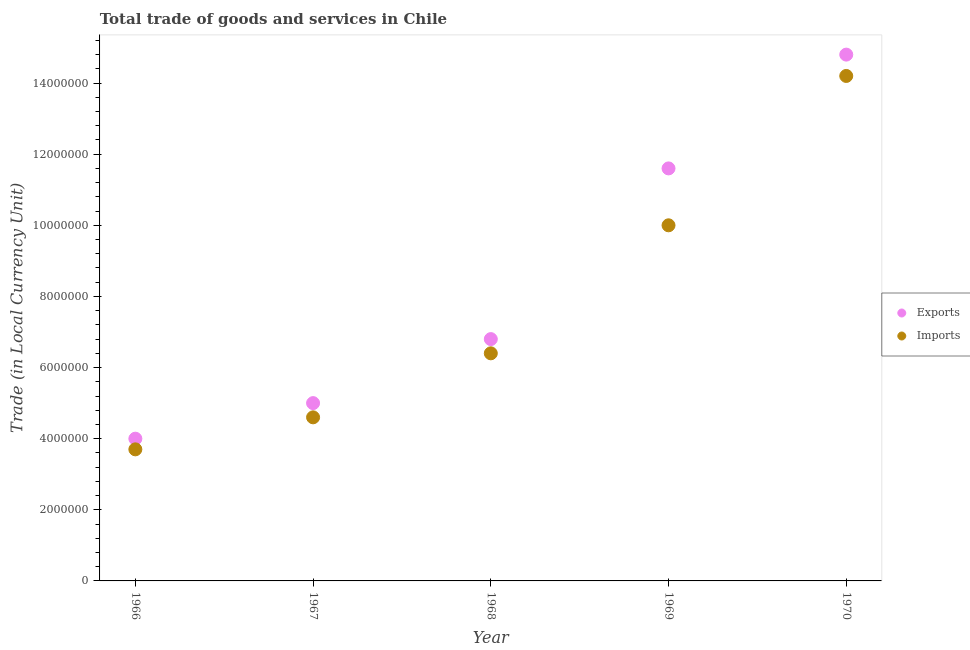How many different coloured dotlines are there?
Your answer should be very brief. 2. What is the imports of goods and services in 1970?
Your answer should be compact. 1.42e+07. Across all years, what is the maximum export of goods and services?
Provide a succinct answer. 1.48e+07. Across all years, what is the minimum imports of goods and services?
Ensure brevity in your answer.  3.70e+06. In which year was the imports of goods and services maximum?
Offer a very short reply. 1970. In which year was the imports of goods and services minimum?
Your answer should be compact. 1966. What is the total imports of goods and services in the graph?
Ensure brevity in your answer.  3.89e+07. What is the difference between the export of goods and services in 1966 and that in 1968?
Keep it short and to the point. -2.80e+06. What is the difference between the export of goods and services in 1968 and the imports of goods and services in 1967?
Provide a succinct answer. 2.20e+06. What is the average export of goods and services per year?
Offer a terse response. 8.44e+06. In the year 1969, what is the difference between the imports of goods and services and export of goods and services?
Offer a very short reply. -1.60e+06. What is the ratio of the imports of goods and services in 1967 to that in 1969?
Your answer should be very brief. 0.46. Is the imports of goods and services in 1966 less than that in 1970?
Provide a short and direct response. Yes. Is the difference between the export of goods and services in 1967 and 1970 greater than the difference between the imports of goods and services in 1967 and 1970?
Keep it short and to the point. No. What is the difference between the highest and the second highest imports of goods and services?
Keep it short and to the point. 4.20e+06. What is the difference between the highest and the lowest imports of goods and services?
Keep it short and to the point. 1.05e+07. How many years are there in the graph?
Your answer should be compact. 5. What is the difference between two consecutive major ticks on the Y-axis?
Give a very brief answer. 2.00e+06. Does the graph contain any zero values?
Offer a terse response. No. How are the legend labels stacked?
Your answer should be very brief. Vertical. What is the title of the graph?
Offer a terse response. Total trade of goods and services in Chile. Does "Nitrous oxide" appear as one of the legend labels in the graph?
Ensure brevity in your answer.  No. What is the label or title of the X-axis?
Provide a succinct answer. Year. What is the label or title of the Y-axis?
Provide a succinct answer. Trade (in Local Currency Unit). What is the Trade (in Local Currency Unit) in Exports in 1966?
Offer a terse response. 4.00e+06. What is the Trade (in Local Currency Unit) of Imports in 1966?
Ensure brevity in your answer.  3.70e+06. What is the Trade (in Local Currency Unit) in Imports in 1967?
Offer a very short reply. 4.60e+06. What is the Trade (in Local Currency Unit) in Exports in 1968?
Offer a very short reply. 6.80e+06. What is the Trade (in Local Currency Unit) in Imports in 1968?
Your answer should be compact. 6.40e+06. What is the Trade (in Local Currency Unit) in Exports in 1969?
Provide a succinct answer. 1.16e+07. What is the Trade (in Local Currency Unit) in Exports in 1970?
Offer a very short reply. 1.48e+07. What is the Trade (in Local Currency Unit) in Imports in 1970?
Offer a terse response. 1.42e+07. Across all years, what is the maximum Trade (in Local Currency Unit) of Exports?
Make the answer very short. 1.48e+07. Across all years, what is the maximum Trade (in Local Currency Unit) of Imports?
Your answer should be compact. 1.42e+07. Across all years, what is the minimum Trade (in Local Currency Unit) in Imports?
Keep it short and to the point. 3.70e+06. What is the total Trade (in Local Currency Unit) in Exports in the graph?
Your answer should be compact. 4.22e+07. What is the total Trade (in Local Currency Unit) in Imports in the graph?
Keep it short and to the point. 3.89e+07. What is the difference between the Trade (in Local Currency Unit) in Imports in 1966 and that in 1967?
Provide a succinct answer. -9.00e+05. What is the difference between the Trade (in Local Currency Unit) of Exports in 1966 and that in 1968?
Make the answer very short. -2.80e+06. What is the difference between the Trade (in Local Currency Unit) in Imports in 1966 and that in 1968?
Offer a very short reply. -2.70e+06. What is the difference between the Trade (in Local Currency Unit) of Exports in 1966 and that in 1969?
Your answer should be compact. -7.60e+06. What is the difference between the Trade (in Local Currency Unit) in Imports in 1966 and that in 1969?
Your answer should be very brief. -6.30e+06. What is the difference between the Trade (in Local Currency Unit) in Exports in 1966 and that in 1970?
Your answer should be compact. -1.08e+07. What is the difference between the Trade (in Local Currency Unit) of Imports in 1966 and that in 1970?
Offer a very short reply. -1.05e+07. What is the difference between the Trade (in Local Currency Unit) of Exports in 1967 and that in 1968?
Your answer should be very brief. -1.80e+06. What is the difference between the Trade (in Local Currency Unit) in Imports in 1967 and that in 1968?
Offer a very short reply. -1.80e+06. What is the difference between the Trade (in Local Currency Unit) in Exports in 1967 and that in 1969?
Offer a very short reply. -6.60e+06. What is the difference between the Trade (in Local Currency Unit) in Imports in 1967 and that in 1969?
Your response must be concise. -5.40e+06. What is the difference between the Trade (in Local Currency Unit) of Exports in 1967 and that in 1970?
Offer a very short reply. -9.80e+06. What is the difference between the Trade (in Local Currency Unit) of Imports in 1967 and that in 1970?
Keep it short and to the point. -9.60e+06. What is the difference between the Trade (in Local Currency Unit) of Exports in 1968 and that in 1969?
Offer a terse response. -4.80e+06. What is the difference between the Trade (in Local Currency Unit) of Imports in 1968 and that in 1969?
Your answer should be compact. -3.60e+06. What is the difference between the Trade (in Local Currency Unit) in Exports in 1968 and that in 1970?
Offer a terse response. -8.00e+06. What is the difference between the Trade (in Local Currency Unit) of Imports in 1968 and that in 1970?
Provide a short and direct response. -7.80e+06. What is the difference between the Trade (in Local Currency Unit) in Exports in 1969 and that in 1970?
Ensure brevity in your answer.  -3.20e+06. What is the difference between the Trade (in Local Currency Unit) in Imports in 1969 and that in 1970?
Offer a terse response. -4.20e+06. What is the difference between the Trade (in Local Currency Unit) of Exports in 1966 and the Trade (in Local Currency Unit) of Imports in 1967?
Ensure brevity in your answer.  -6.00e+05. What is the difference between the Trade (in Local Currency Unit) of Exports in 1966 and the Trade (in Local Currency Unit) of Imports in 1968?
Give a very brief answer. -2.40e+06. What is the difference between the Trade (in Local Currency Unit) in Exports in 1966 and the Trade (in Local Currency Unit) in Imports in 1969?
Your answer should be very brief. -6.00e+06. What is the difference between the Trade (in Local Currency Unit) of Exports in 1966 and the Trade (in Local Currency Unit) of Imports in 1970?
Provide a succinct answer. -1.02e+07. What is the difference between the Trade (in Local Currency Unit) in Exports in 1967 and the Trade (in Local Currency Unit) in Imports in 1968?
Provide a succinct answer. -1.40e+06. What is the difference between the Trade (in Local Currency Unit) in Exports in 1967 and the Trade (in Local Currency Unit) in Imports in 1969?
Offer a terse response. -5.00e+06. What is the difference between the Trade (in Local Currency Unit) of Exports in 1967 and the Trade (in Local Currency Unit) of Imports in 1970?
Offer a very short reply. -9.20e+06. What is the difference between the Trade (in Local Currency Unit) of Exports in 1968 and the Trade (in Local Currency Unit) of Imports in 1969?
Your response must be concise. -3.20e+06. What is the difference between the Trade (in Local Currency Unit) in Exports in 1968 and the Trade (in Local Currency Unit) in Imports in 1970?
Give a very brief answer. -7.40e+06. What is the difference between the Trade (in Local Currency Unit) of Exports in 1969 and the Trade (in Local Currency Unit) of Imports in 1970?
Keep it short and to the point. -2.60e+06. What is the average Trade (in Local Currency Unit) in Exports per year?
Provide a short and direct response. 8.44e+06. What is the average Trade (in Local Currency Unit) in Imports per year?
Your answer should be very brief. 7.78e+06. In the year 1968, what is the difference between the Trade (in Local Currency Unit) in Exports and Trade (in Local Currency Unit) in Imports?
Offer a terse response. 4.00e+05. In the year 1969, what is the difference between the Trade (in Local Currency Unit) in Exports and Trade (in Local Currency Unit) in Imports?
Your answer should be very brief. 1.60e+06. In the year 1970, what is the difference between the Trade (in Local Currency Unit) in Exports and Trade (in Local Currency Unit) in Imports?
Ensure brevity in your answer.  6.00e+05. What is the ratio of the Trade (in Local Currency Unit) in Exports in 1966 to that in 1967?
Offer a very short reply. 0.8. What is the ratio of the Trade (in Local Currency Unit) of Imports in 1966 to that in 1967?
Offer a terse response. 0.8. What is the ratio of the Trade (in Local Currency Unit) of Exports in 1966 to that in 1968?
Ensure brevity in your answer.  0.59. What is the ratio of the Trade (in Local Currency Unit) of Imports in 1966 to that in 1968?
Your response must be concise. 0.58. What is the ratio of the Trade (in Local Currency Unit) in Exports in 1966 to that in 1969?
Ensure brevity in your answer.  0.34. What is the ratio of the Trade (in Local Currency Unit) in Imports in 1966 to that in 1969?
Ensure brevity in your answer.  0.37. What is the ratio of the Trade (in Local Currency Unit) in Exports in 1966 to that in 1970?
Your response must be concise. 0.27. What is the ratio of the Trade (in Local Currency Unit) of Imports in 1966 to that in 1970?
Offer a very short reply. 0.26. What is the ratio of the Trade (in Local Currency Unit) of Exports in 1967 to that in 1968?
Your answer should be very brief. 0.74. What is the ratio of the Trade (in Local Currency Unit) in Imports in 1967 to that in 1968?
Offer a very short reply. 0.72. What is the ratio of the Trade (in Local Currency Unit) in Exports in 1967 to that in 1969?
Ensure brevity in your answer.  0.43. What is the ratio of the Trade (in Local Currency Unit) of Imports in 1967 to that in 1969?
Offer a very short reply. 0.46. What is the ratio of the Trade (in Local Currency Unit) in Exports in 1967 to that in 1970?
Your answer should be compact. 0.34. What is the ratio of the Trade (in Local Currency Unit) in Imports in 1967 to that in 1970?
Offer a very short reply. 0.32. What is the ratio of the Trade (in Local Currency Unit) in Exports in 1968 to that in 1969?
Provide a succinct answer. 0.59. What is the ratio of the Trade (in Local Currency Unit) in Imports in 1968 to that in 1969?
Your answer should be compact. 0.64. What is the ratio of the Trade (in Local Currency Unit) of Exports in 1968 to that in 1970?
Provide a short and direct response. 0.46. What is the ratio of the Trade (in Local Currency Unit) in Imports in 1968 to that in 1970?
Your answer should be compact. 0.45. What is the ratio of the Trade (in Local Currency Unit) of Exports in 1969 to that in 1970?
Provide a succinct answer. 0.78. What is the ratio of the Trade (in Local Currency Unit) in Imports in 1969 to that in 1970?
Make the answer very short. 0.7. What is the difference between the highest and the second highest Trade (in Local Currency Unit) in Exports?
Give a very brief answer. 3.20e+06. What is the difference between the highest and the second highest Trade (in Local Currency Unit) of Imports?
Provide a short and direct response. 4.20e+06. What is the difference between the highest and the lowest Trade (in Local Currency Unit) in Exports?
Your answer should be very brief. 1.08e+07. What is the difference between the highest and the lowest Trade (in Local Currency Unit) in Imports?
Offer a terse response. 1.05e+07. 